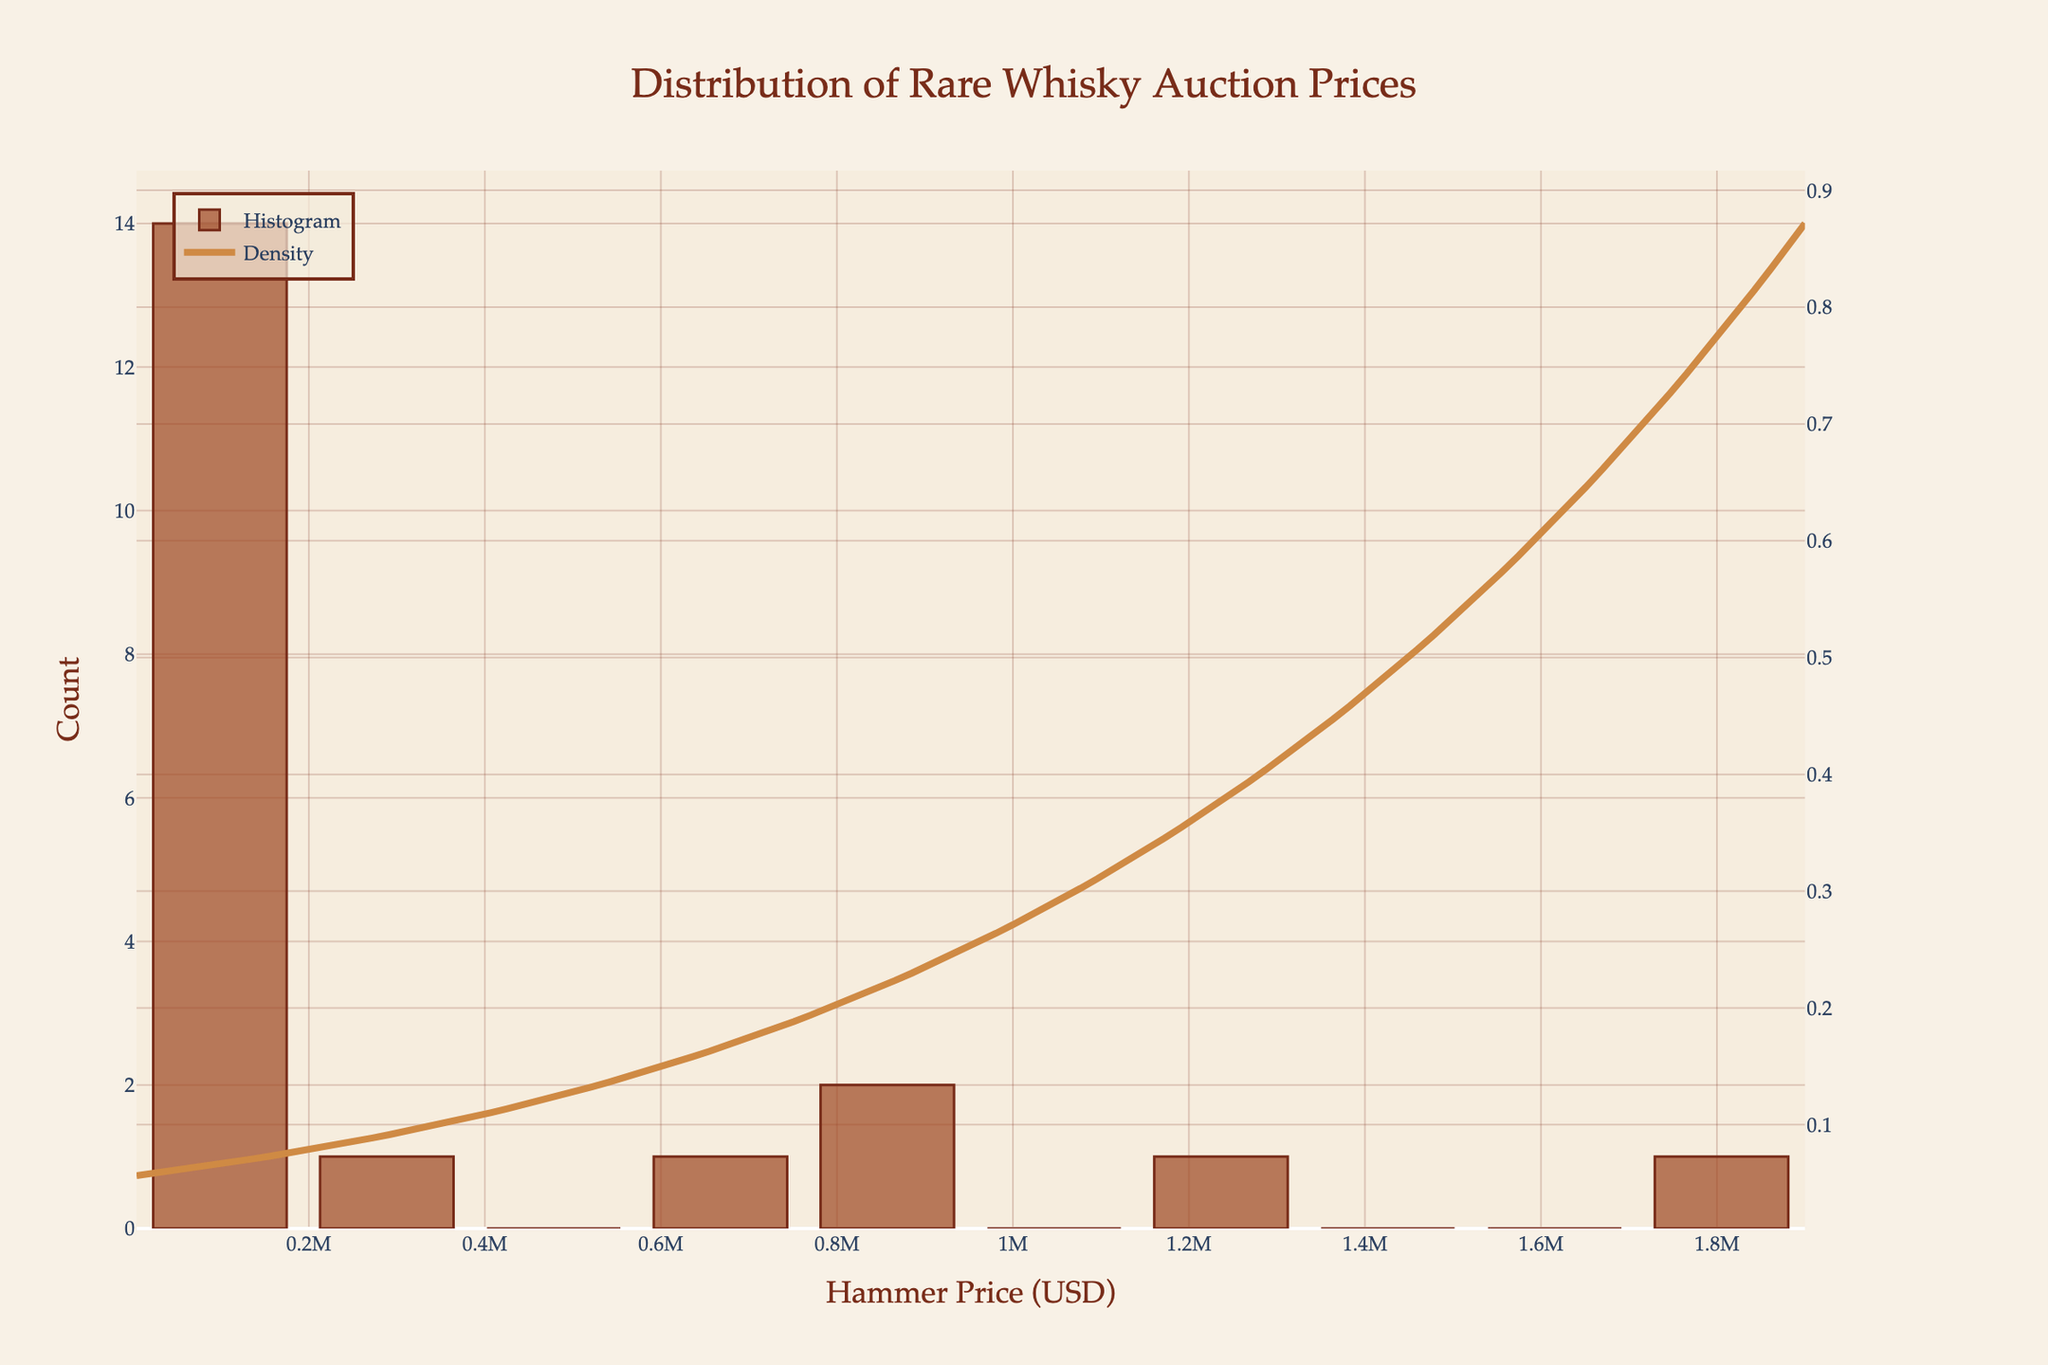What is the title of the figure? The title of the figure is written at the top and describes the main subject of the plot. The title is "Distribution of Rare Whisky Auction Prices".
Answer: Distribution of Rare Whisky Auction Prices What is displayed on the x-axis? The x-axis represents the hammer price in USD for the whisky auctions. It is labeled "Hammer Price (USD)".
Answer: Hammer Price (USD) What does the y-axis show? The primary y-axis on the left shows the count of the auction hammer prices within each bin. It is labeled "Count".
Answer: Count Which whisky had the highest hammer price and what was it? The whisky with the highest hammer price would be seen as the highest bar in the histogram or identified as the highest point on the data range. The Macallan 1926 Fine & Rare 60 Year Old had the highest hammer price at 1,900,000 USD.
Answer: Macallan 1926 Fine & Rare 60 Year Old, 1,900,000 USD How many whiskies were auctioned for less than 100,000 USD? To answer this, add the counts from bins in the histogram that represent hammer prices less than 100,000 USD. By examining the histogram bins, we find there are 13 whiskies that fit this criterion.
Answer: 13 How does the density (KDE curve) behave in the lower price range below 100,000 USD? The density curve showing the KDE suggests how data points are distributed. Below 100,000 USD, the curve shows higher density, indicating a higher concentration of auction prices in this range.
Answer: Higher density below 100,000 USD What can you infer from the height and spread of the KDE curve? The height and spread of the KDE curve provide insight into the distribution pattern of the hammer prices. A taller peak indicates more data points (higher density) around that value, and the spread shows variability across the price range. The KDE curve shows a peak at lower prices, indicating many more whiskies sold for lower prices.
Answer: Higher density at lower prices, more variability at higher prices Which whisky has the second-highest hammer price, and how does it compare to the highest? The second-highest hammer price can be identified just below the highest bin or point on the histogram. The Dalmore Paterson Collection is the second highest at 1,200,000 USD, considerably less than the Macallan 1926 Fine & Rare 60 Year Old at 1,900,000 USD.
Answer: Dalmore Paterson Collection, 1,200,000 USD How does the histogram illustrate the trend in hammer prices among whiskies? The histogram reveals frequency through bar heights for different price ranges. Higher bars at the lower price range and fewer, shorter bars at the higher range show that most whiskies are auctioned at lower prices, with a few exceptions at very high prices.
Answer: Most whiskies at lower prices, few at higher prices 